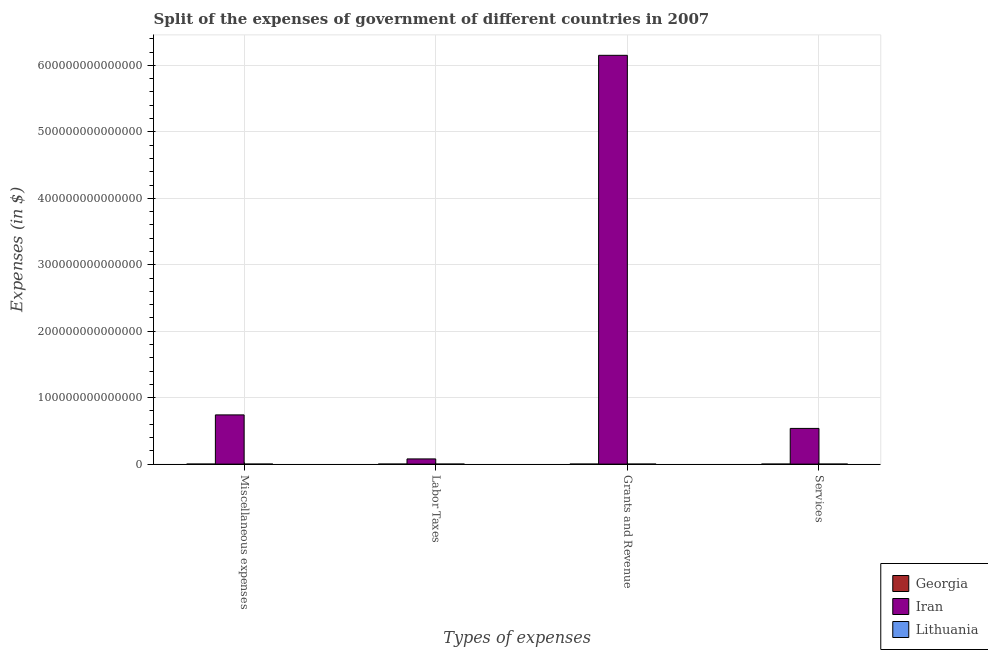Are the number of bars on each tick of the X-axis equal?
Ensure brevity in your answer.  Yes. How many bars are there on the 1st tick from the right?
Your answer should be compact. 3. What is the label of the 3rd group of bars from the left?
Keep it short and to the point. Grants and Revenue. What is the amount spent on grants and revenue in Lithuania?
Ensure brevity in your answer.  3.42e+09. Across all countries, what is the maximum amount spent on miscellaneous expenses?
Give a very brief answer. 7.41e+13. Across all countries, what is the minimum amount spent on grants and revenue?
Provide a succinct answer. 5.61e+08. In which country was the amount spent on miscellaneous expenses maximum?
Provide a succinct answer. Iran. In which country was the amount spent on labor taxes minimum?
Your answer should be compact. Georgia. What is the total amount spent on labor taxes in the graph?
Keep it short and to the point. 7.82e+12. What is the difference between the amount spent on services in Georgia and that in Lithuania?
Provide a short and direct response. -2.10e+09. What is the difference between the amount spent on miscellaneous expenses in Lithuania and the amount spent on labor taxes in Georgia?
Keep it short and to the point. 2.56e+09. What is the average amount spent on labor taxes per country?
Offer a very short reply. 2.61e+12. What is the difference between the amount spent on services and amount spent on labor taxes in Lithuania?
Offer a very short reply. 3.54e+09. What is the ratio of the amount spent on labor taxes in Georgia to that in Lithuania?
Keep it short and to the point. 0.58. Is the difference between the amount spent on labor taxes in Iran and Lithuania greater than the difference between the amount spent on services in Iran and Lithuania?
Ensure brevity in your answer.  No. What is the difference between the highest and the second highest amount spent on miscellaneous expenses?
Your response must be concise. 7.41e+13. What is the difference between the highest and the lowest amount spent on services?
Provide a succinct answer. 5.37e+13. Is the sum of the amount spent on miscellaneous expenses in Georgia and Iran greater than the maximum amount spent on grants and revenue across all countries?
Offer a very short reply. No. What does the 1st bar from the left in Labor Taxes represents?
Offer a terse response. Georgia. What does the 1st bar from the right in Miscellaneous expenses represents?
Your response must be concise. Lithuania. Are all the bars in the graph horizontal?
Keep it short and to the point. No. How many countries are there in the graph?
Your answer should be compact. 3. What is the difference between two consecutive major ticks on the Y-axis?
Ensure brevity in your answer.  1.00e+14. Are the values on the major ticks of Y-axis written in scientific E-notation?
Your answer should be compact. No. How many legend labels are there?
Provide a short and direct response. 3. What is the title of the graph?
Keep it short and to the point. Split of the expenses of government of different countries in 2007. What is the label or title of the X-axis?
Offer a very short reply. Types of expenses. What is the label or title of the Y-axis?
Make the answer very short. Expenses (in $). What is the Expenses (in $) in Georgia in Miscellaneous expenses?
Give a very brief answer. 3.48e+08. What is the Expenses (in $) of Iran in Miscellaneous expenses?
Give a very brief answer. 7.41e+13. What is the Expenses (in $) in Lithuania in Miscellaneous expenses?
Keep it short and to the point. 2.58e+09. What is the Expenses (in $) in Georgia in Labor Taxes?
Give a very brief answer. 2.31e+07. What is the Expenses (in $) of Iran in Labor Taxes?
Ensure brevity in your answer.  7.82e+12. What is the Expenses (in $) in Lithuania in Labor Taxes?
Your response must be concise. 3.97e+07. What is the Expenses (in $) of Georgia in Grants and Revenue?
Your answer should be very brief. 5.61e+08. What is the Expenses (in $) in Iran in Grants and Revenue?
Your answer should be compact. 6.15e+14. What is the Expenses (in $) of Lithuania in Grants and Revenue?
Keep it short and to the point. 3.42e+09. What is the Expenses (in $) in Georgia in Services?
Give a very brief answer. 1.48e+09. What is the Expenses (in $) in Iran in Services?
Provide a succinct answer. 5.37e+13. What is the Expenses (in $) of Lithuania in Services?
Provide a short and direct response. 3.58e+09. Across all Types of expenses, what is the maximum Expenses (in $) in Georgia?
Your answer should be very brief. 1.48e+09. Across all Types of expenses, what is the maximum Expenses (in $) in Iran?
Ensure brevity in your answer.  6.15e+14. Across all Types of expenses, what is the maximum Expenses (in $) of Lithuania?
Provide a short and direct response. 3.58e+09. Across all Types of expenses, what is the minimum Expenses (in $) in Georgia?
Your response must be concise. 2.31e+07. Across all Types of expenses, what is the minimum Expenses (in $) in Iran?
Your answer should be very brief. 7.82e+12. Across all Types of expenses, what is the minimum Expenses (in $) in Lithuania?
Keep it short and to the point. 3.97e+07. What is the total Expenses (in $) in Georgia in the graph?
Your answer should be very brief. 2.42e+09. What is the total Expenses (in $) of Iran in the graph?
Your response must be concise. 7.51e+14. What is the total Expenses (in $) of Lithuania in the graph?
Your answer should be very brief. 9.62e+09. What is the difference between the Expenses (in $) of Georgia in Miscellaneous expenses and that in Labor Taxes?
Offer a very short reply. 3.25e+08. What is the difference between the Expenses (in $) in Iran in Miscellaneous expenses and that in Labor Taxes?
Offer a terse response. 6.63e+13. What is the difference between the Expenses (in $) of Lithuania in Miscellaneous expenses and that in Labor Taxes?
Your answer should be compact. 2.54e+09. What is the difference between the Expenses (in $) in Georgia in Miscellaneous expenses and that in Grants and Revenue?
Provide a short and direct response. -2.13e+08. What is the difference between the Expenses (in $) in Iran in Miscellaneous expenses and that in Grants and Revenue?
Provide a short and direct response. -5.41e+14. What is the difference between the Expenses (in $) in Lithuania in Miscellaneous expenses and that in Grants and Revenue?
Offer a very short reply. -8.37e+08. What is the difference between the Expenses (in $) of Georgia in Miscellaneous expenses and that in Services?
Your answer should be compact. -1.14e+09. What is the difference between the Expenses (in $) in Iran in Miscellaneous expenses and that in Services?
Ensure brevity in your answer.  2.03e+13. What is the difference between the Expenses (in $) in Lithuania in Miscellaneous expenses and that in Services?
Give a very brief answer. -9.99e+08. What is the difference between the Expenses (in $) of Georgia in Labor Taxes and that in Grants and Revenue?
Provide a short and direct response. -5.38e+08. What is the difference between the Expenses (in $) in Iran in Labor Taxes and that in Grants and Revenue?
Your response must be concise. -6.07e+14. What is the difference between the Expenses (in $) in Lithuania in Labor Taxes and that in Grants and Revenue?
Provide a succinct answer. -3.38e+09. What is the difference between the Expenses (in $) in Georgia in Labor Taxes and that in Services?
Your answer should be very brief. -1.46e+09. What is the difference between the Expenses (in $) of Iran in Labor Taxes and that in Services?
Provide a short and direct response. -4.59e+13. What is the difference between the Expenses (in $) of Lithuania in Labor Taxes and that in Services?
Provide a short and direct response. -3.54e+09. What is the difference between the Expenses (in $) of Georgia in Grants and Revenue and that in Services?
Offer a very short reply. -9.23e+08. What is the difference between the Expenses (in $) in Iran in Grants and Revenue and that in Services?
Provide a short and direct response. 5.61e+14. What is the difference between the Expenses (in $) of Lithuania in Grants and Revenue and that in Services?
Make the answer very short. -1.62e+08. What is the difference between the Expenses (in $) of Georgia in Miscellaneous expenses and the Expenses (in $) of Iran in Labor Taxes?
Provide a succinct answer. -7.82e+12. What is the difference between the Expenses (in $) in Georgia in Miscellaneous expenses and the Expenses (in $) in Lithuania in Labor Taxes?
Keep it short and to the point. 3.08e+08. What is the difference between the Expenses (in $) of Iran in Miscellaneous expenses and the Expenses (in $) of Lithuania in Labor Taxes?
Your response must be concise. 7.41e+13. What is the difference between the Expenses (in $) of Georgia in Miscellaneous expenses and the Expenses (in $) of Iran in Grants and Revenue?
Provide a short and direct response. -6.15e+14. What is the difference between the Expenses (in $) in Georgia in Miscellaneous expenses and the Expenses (in $) in Lithuania in Grants and Revenue?
Your answer should be compact. -3.07e+09. What is the difference between the Expenses (in $) of Iran in Miscellaneous expenses and the Expenses (in $) of Lithuania in Grants and Revenue?
Provide a short and direct response. 7.41e+13. What is the difference between the Expenses (in $) of Georgia in Miscellaneous expenses and the Expenses (in $) of Iran in Services?
Keep it short and to the point. -5.37e+13. What is the difference between the Expenses (in $) in Georgia in Miscellaneous expenses and the Expenses (in $) in Lithuania in Services?
Offer a very short reply. -3.23e+09. What is the difference between the Expenses (in $) in Iran in Miscellaneous expenses and the Expenses (in $) in Lithuania in Services?
Provide a succinct answer. 7.41e+13. What is the difference between the Expenses (in $) in Georgia in Labor Taxes and the Expenses (in $) in Iran in Grants and Revenue?
Your answer should be compact. -6.15e+14. What is the difference between the Expenses (in $) of Georgia in Labor Taxes and the Expenses (in $) of Lithuania in Grants and Revenue?
Offer a terse response. -3.40e+09. What is the difference between the Expenses (in $) in Iran in Labor Taxes and the Expenses (in $) in Lithuania in Grants and Revenue?
Your answer should be compact. 7.81e+12. What is the difference between the Expenses (in $) in Georgia in Labor Taxes and the Expenses (in $) in Iran in Services?
Make the answer very short. -5.37e+13. What is the difference between the Expenses (in $) of Georgia in Labor Taxes and the Expenses (in $) of Lithuania in Services?
Provide a succinct answer. -3.56e+09. What is the difference between the Expenses (in $) of Iran in Labor Taxes and the Expenses (in $) of Lithuania in Services?
Your answer should be compact. 7.81e+12. What is the difference between the Expenses (in $) of Georgia in Grants and Revenue and the Expenses (in $) of Iran in Services?
Provide a succinct answer. -5.37e+13. What is the difference between the Expenses (in $) of Georgia in Grants and Revenue and the Expenses (in $) of Lithuania in Services?
Make the answer very short. -3.02e+09. What is the difference between the Expenses (in $) in Iran in Grants and Revenue and the Expenses (in $) in Lithuania in Services?
Your response must be concise. 6.15e+14. What is the average Expenses (in $) in Georgia per Types of expenses?
Your response must be concise. 6.04e+08. What is the average Expenses (in $) in Iran per Types of expenses?
Ensure brevity in your answer.  1.88e+14. What is the average Expenses (in $) in Lithuania per Types of expenses?
Offer a very short reply. 2.41e+09. What is the difference between the Expenses (in $) in Georgia and Expenses (in $) in Iran in Miscellaneous expenses?
Keep it short and to the point. -7.41e+13. What is the difference between the Expenses (in $) in Georgia and Expenses (in $) in Lithuania in Miscellaneous expenses?
Your answer should be compact. -2.23e+09. What is the difference between the Expenses (in $) in Iran and Expenses (in $) in Lithuania in Miscellaneous expenses?
Your answer should be compact. 7.41e+13. What is the difference between the Expenses (in $) of Georgia and Expenses (in $) of Iran in Labor Taxes?
Ensure brevity in your answer.  -7.82e+12. What is the difference between the Expenses (in $) in Georgia and Expenses (in $) in Lithuania in Labor Taxes?
Make the answer very short. -1.66e+07. What is the difference between the Expenses (in $) in Iran and Expenses (in $) in Lithuania in Labor Taxes?
Offer a terse response. 7.82e+12. What is the difference between the Expenses (in $) in Georgia and Expenses (in $) in Iran in Grants and Revenue?
Your answer should be compact. -6.15e+14. What is the difference between the Expenses (in $) of Georgia and Expenses (in $) of Lithuania in Grants and Revenue?
Offer a terse response. -2.86e+09. What is the difference between the Expenses (in $) of Iran and Expenses (in $) of Lithuania in Grants and Revenue?
Your answer should be compact. 6.15e+14. What is the difference between the Expenses (in $) of Georgia and Expenses (in $) of Iran in Services?
Offer a very short reply. -5.37e+13. What is the difference between the Expenses (in $) in Georgia and Expenses (in $) in Lithuania in Services?
Give a very brief answer. -2.10e+09. What is the difference between the Expenses (in $) of Iran and Expenses (in $) of Lithuania in Services?
Your answer should be very brief. 5.37e+13. What is the ratio of the Expenses (in $) in Georgia in Miscellaneous expenses to that in Labor Taxes?
Give a very brief answer. 15.07. What is the ratio of the Expenses (in $) in Iran in Miscellaneous expenses to that in Labor Taxes?
Provide a short and direct response. 9.48. What is the ratio of the Expenses (in $) in Lithuania in Miscellaneous expenses to that in Labor Taxes?
Your answer should be compact. 65.06. What is the ratio of the Expenses (in $) of Georgia in Miscellaneous expenses to that in Grants and Revenue?
Provide a succinct answer. 0.62. What is the ratio of the Expenses (in $) of Iran in Miscellaneous expenses to that in Grants and Revenue?
Provide a succinct answer. 0.12. What is the ratio of the Expenses (in $) in Lithuania in Miscellaneous expenses to that in Grants and Revenue?
Provide a short and direct response. 0.76. What is the ratio of the Expenses (in $) of Georgia in Miscellaneous expenses to that in Services?
Your answer should be compact. 0.23. What is the ratio of the Expenses (in $) of Iran in Miscellaneous expenses to that in Services?
Your answer should be very brief. 1.38. What is the ratio of the Expenses (in $) of Lithuania in Miscellaneous expenses to that in Services?
Offer a very short reply. 0.72. What is the ratio of the Expenses (in $) of Georgia in Labor Taxes to that in Grants and Revenue?
Give a very brief answer. 0.04. What is the ratio of the Expenses (in $) of Iran in Labor Taxes to that in Grants and Revenue?
Provide a short and direct response. 0.01. What is the ratio of the Expenses (in $) in Lithuania in Labor Taxes to that in Grants and Revenue?
Your response must be concise. 0.01. What is the ratio of the Expenses (in $) in Georgia in Labor Taxes to that in Services?
Provide a succinct answer. 0.02. What is the ratio of the Expenses (in $) of Iran in Labor Taxes to that in Services?
Give a very brief answer. 0.15. What is the ratio of the Expenses (in $) in Lithuania in Labor Taxes to that in Services?
Give a very brief answer. 0.01. What is the ratio of the Expenses (in $) in Georgia in Grants and Revenue to that in Services?
Provide a succinct answer. 0.38. What is the ratio of the Expenses (in $) in Iran in Grants and Revenue to that in Services?
Offer a very short reply. 11.45. What is the ratio of the Expenses (in $) of Lithuania in Grants and Revenue to that in Services?
Make the answer very short. 0.95. What is the difference between the highest and the second highest Expenses (in $) of Georgia?
Provide a succinct answer. 9.23e+08. What is the difference between the highest and the second highest Expenses (in $) of Iran?
Keep it short and to the point. 5.41e+14. What is the difference between the highest and the second highest Expenses (in $) of Lithuania?
Your answer should be compact. 1.62e+08. What is the difference between the highest and the lowest Expenses (in $) in Georgia?
Your answer should be very brief. 1.46e+09. What is the difference between the highest and the lowest Expenses (in $) of Iran?
Provide a succinct answer. 6.07e+14. What is the difference between the highest and the lowest Expenses (in $) in Lithuania?
Your response must be concise. 3.54e+09. 